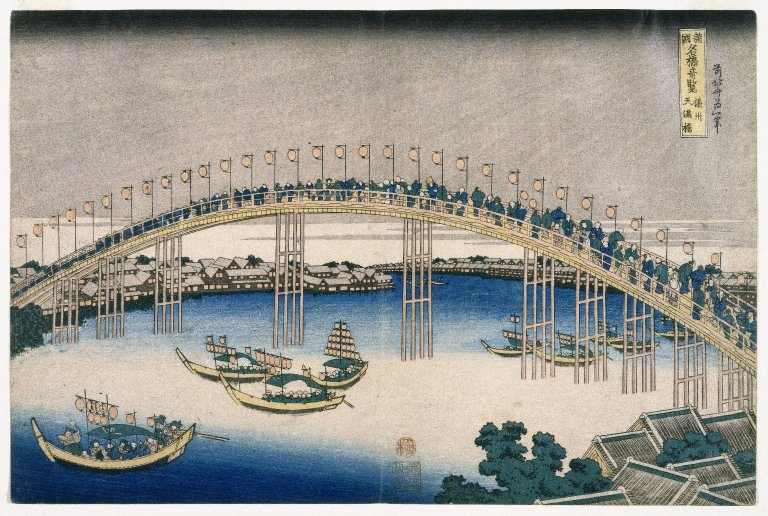What is this photo about'?
 The image is a captivating representation of a bustling scene in Japan, captured through the traditional art form of ukiyo-e. Dominating the scene is a large arching bridge, teeming with people going about their day. The bridge, a symbol of connection, spans over a lively river that is dotted with boats, suggesting a thriving waterway.

On the far shore, buildings peek through, indicating a settlement or perhaps a bustling cityscape. The color palette is a soothing blend of mainly blue and white, with hints of green and brown adding depth and contrast to the scene. The overall genre of the artwork is landscape, a common theme in ukiyo-e art, which often captures the beauty and vibrancy of life in Japan. The image is a testament to the artist's ability to capture a moment in time, bringing to life the everyday scenes of historical Japan. 